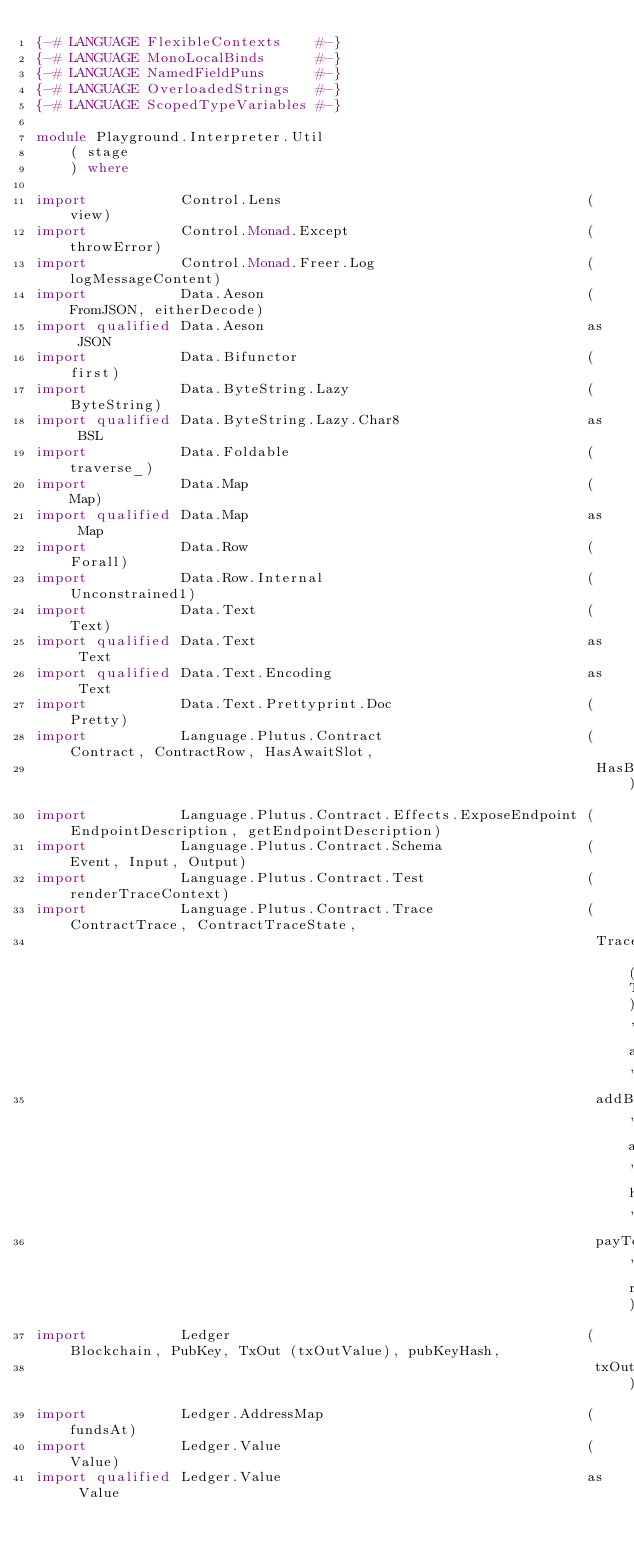Convert code to text. <code><loc_0><loc_0><loc_500><loc_500><_Haskell_>{-# LANGUAGE FlexibleContexts    #-}
{-# LANGUAGE MonoLocalBinds      #-}
{-# LANGUAGE NamedFieldPuns      #-}
{-# LANGUAGE OverloadedStrings   #-}
{-# LANGUAGE ScopedTypeVariables #-}

module Playground.Interpreter.Util
    ( stage
    ) where

import           Control.Lens                                    (view)
import           Control.Monad.Except                            (throwError)
import           Control.Monad.Freer.Log                         (logMessageContent)
import           Data.Aeson                                      (FromJSON, eitherDecode)
import qualified Data.Aeson                                      as JSON
import           Data.Bifunctor                                  (first)
import           Data.ByteString.Lazy                            (ByteString)
import qualified Data.ByteString.Lazy.Char8                      as BSL
import           Data.Foldable                                   (traverse_)
import           Data.Map                                        (Map)
import qualified Data.Map                                        as Map
import           Data.Row                                        (Forall)
import           Data.Row.Internal                               (Unconstrained1)
import           Data.Text                                       (Text)
import qualified Data.Text                                       as Text
import qualified Data.Text.Encoding                              as Text
import           Data.Text.Prettyprint.Doc                       (Pretty)
import           Language.Plutus.Contract                        (Contract, ContractRow, HasAwaitSlot,
                                                                  HasBlockchainActions)
import           Language.Plutus.Contract.Effects.ExposeEndpoint (EndpointDescription, getEndpointDescription)
import           Language.Plutus.Contract.Schema                 (Event, Input, Output)
import           Language.Plutus.Contract.Test                   (renderTraceContext)
import           Language.Plutus.Contract.Trace                  (ContractTrace, ContractTraceState,
                                                                  TraceError (TContractError), addBlocks,
                                                                  addBlocksUntil, addNamedEvent, handleBlockchainEvents,
                                                                  payToWallet, runTraceWithDistribution)
import           Ledger                                          (Blockchain, PubKey, TxOut (txOutValue), pubKeyHash,
                                                                  txOutTxOut)
import           Ledger.AddressMap                               (fundsAt)
import           Ledger.Value                                    (Value)
import qualified Ledger.Value                                    as Value</code> 